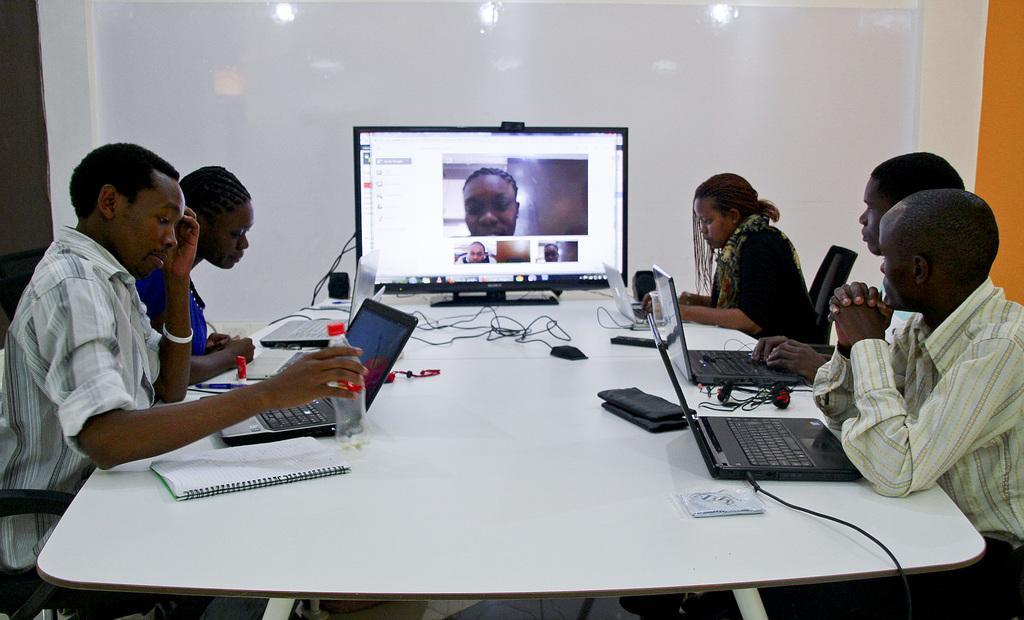Describe this image in one or two sentences. In this image we can see a group of people wearing dress are sitting in front of a table. One person is holding a bottle in his hand. One woman is operating the laptop. On the table we can see a group of laptops, headphones and group of cables and in the background, we can see a television and a wall. 